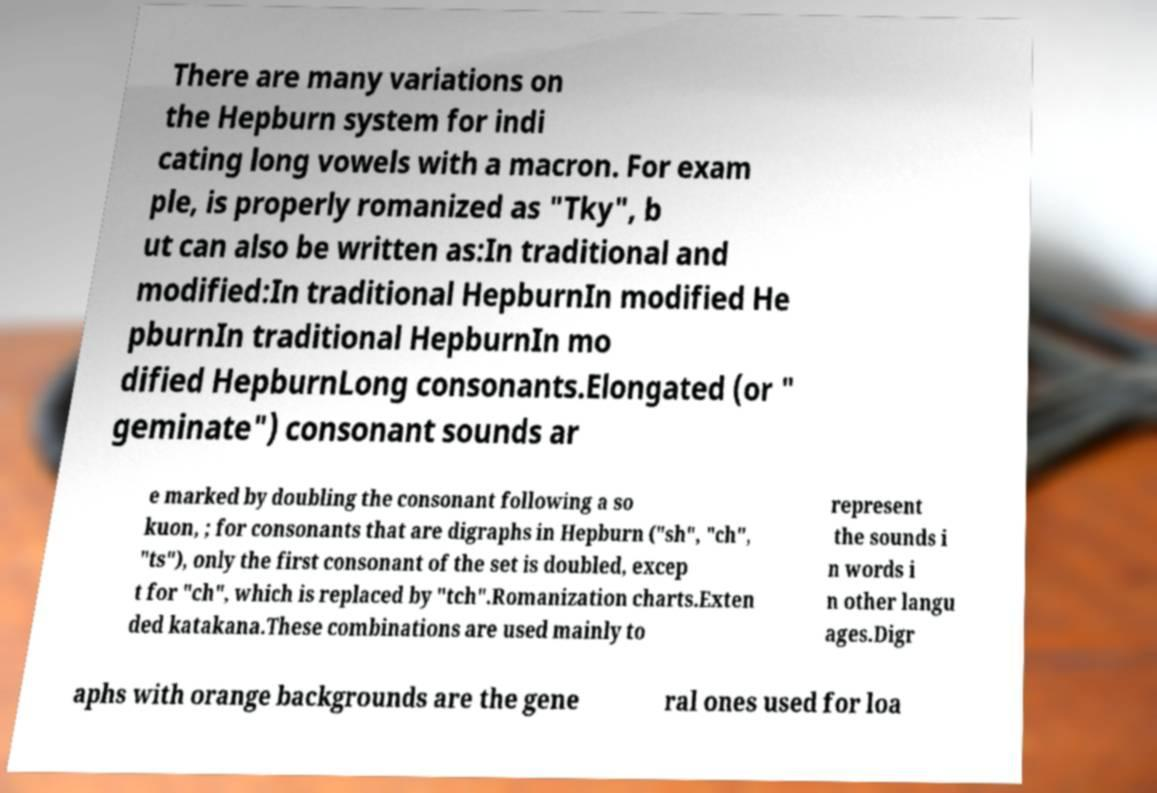Can you read and provide the text displayed in the image?This photo seems to have some interesting text. Can you extract and type it out for me? There are many variations on the Hepburn system for indi cating long vowels with a macron. For exam ple, is properly romanized as "Tky", b ut can also be written as:In traditional and modified:In traditional HepburnIn modified He pburnIn traditional HepburnIn mo dified HepburnLong consonants.Elongated (or " geminate") consonant sounds ar e marked by doubling the consonant following a so kuon, ; for consonants that are digraphs in Hepburn ("sh", "ch", "ts"), only the first consonant of the set is doubled, excep t for "ch", which is replaced by "tch".Romanization charts.Exten ded katakana.These combinations are used mainly to represent the sounds i n words i n other langu ages.Digr aphs with orange backgrounds are the gene ral ones used for loa 